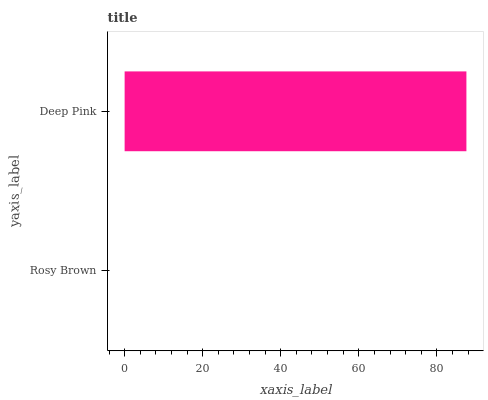Is Rosy Brown the minimum?
Answer yes or no. Yes. Is Deep Pink the maximum?
Answer yes or no. Yes. Is Deep Pink the minimum?
Answer yes or no. No. Is Deep Pink greater than Rosy Brown?
Answer yes or no. Yes. Is Rosy Brown less than Deep Pink?
Answer yes or no. Yes. Is Rosy Brown greater than Deep Pink?
Answer yes or no. No. Is Deep Pink less than Rosy Brown?
Answer yes or no. No. Is Deep Pink the high median?
Answer yes or no. Yes. Is Rosy Brown the low median?
Answer yes or no. Yes. Is Rosy Brown the high median?
Answer yes or no. No. Is Deep Pink the low median?
Answer yes or no. No. 